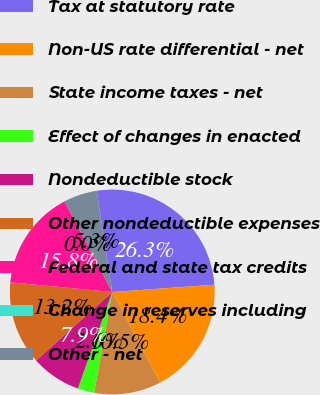<chart> <loc_0><loc_0><loc_500><loc_500><pie_chart><fcel>Tax at statutory rate<fcel>Non-US rate differential - net<fcel>State income taxes - net<fcel>Effect of changes in enacted<fcel>Nondeductible stock<fcel>Other nondeductible expenses<fcel>Federal and state tax credits<fcel>Change in reserves including<fcel>Other - net<nl><fcel>26.31%<fcel>18.42%<fcel>10.53%<fcel>2.63%<fcel>7.9%<fcel>13.16%<fcel>15.79%<fcel>0.0%<fcel>5.26%<nl></chart> 